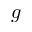<formula> <loc_0><loc_0><loc_500><loc_500>g</formula> 